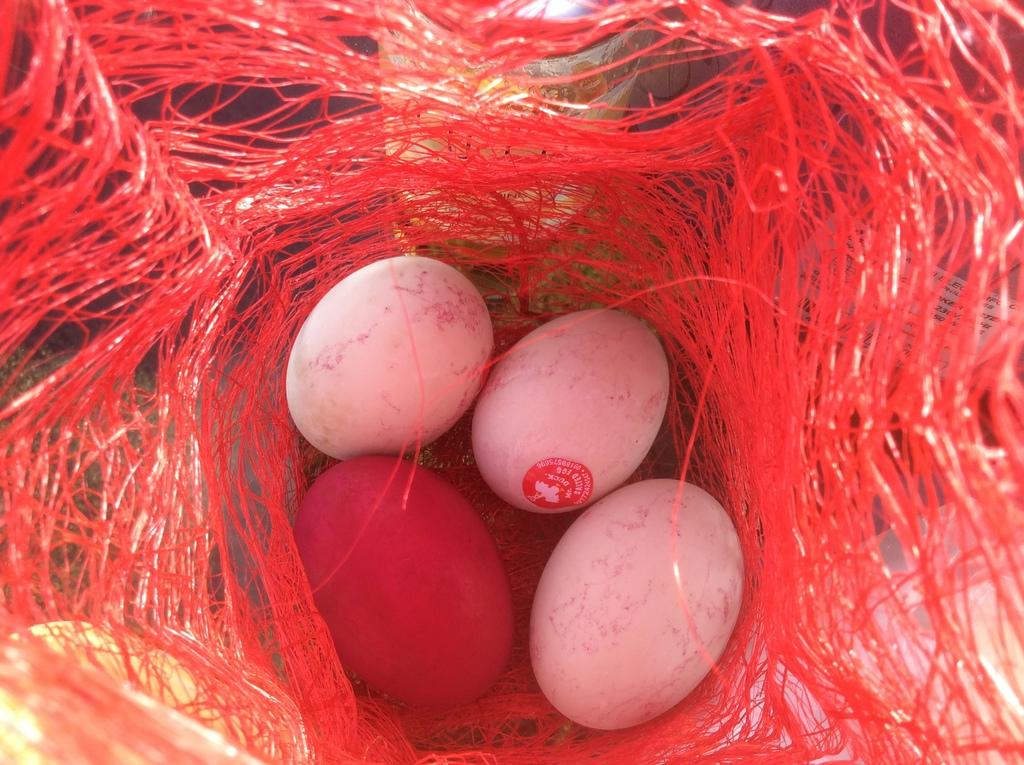What is the primary color of the net in the image? The primary color of the net in the image is red. How many eggs are present in the net? There are four eggs in the net, three of which are white and one is red. What is the color of the red egg in the net? The red egg in the net is red in color. Where is the sock placed on the desk in the image? There is no sock or desk present in the image; it only features a red color net with eggs. 